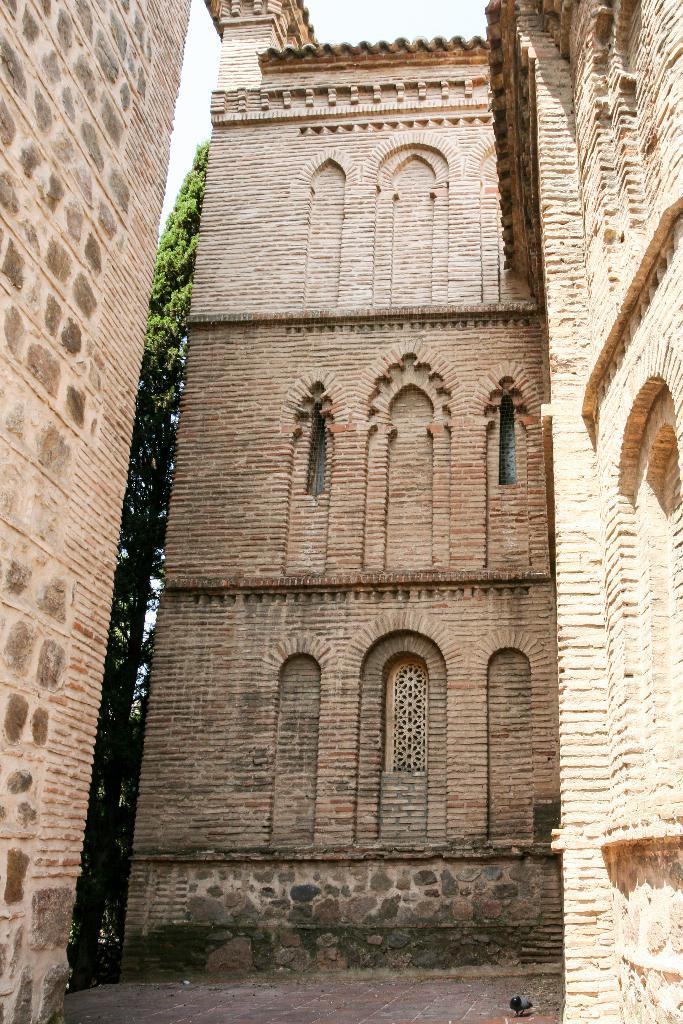What type of structures are present in the image? There are buildings in the image. What is the color of the buildings? The buildings are brown in color. What other natural elements can be seen in the image? There are trees in the image. What is visible part of the environment is not man-made? The sky is visible in the background of the image, which is a natural element. What unexpected element can be found in the image? There is a bird on the floor in the image. How many bubbles are floating around the buildings in the image? There are no bubbles present in the image; it features buildings, trees, the sky, and a bird on the floor. 